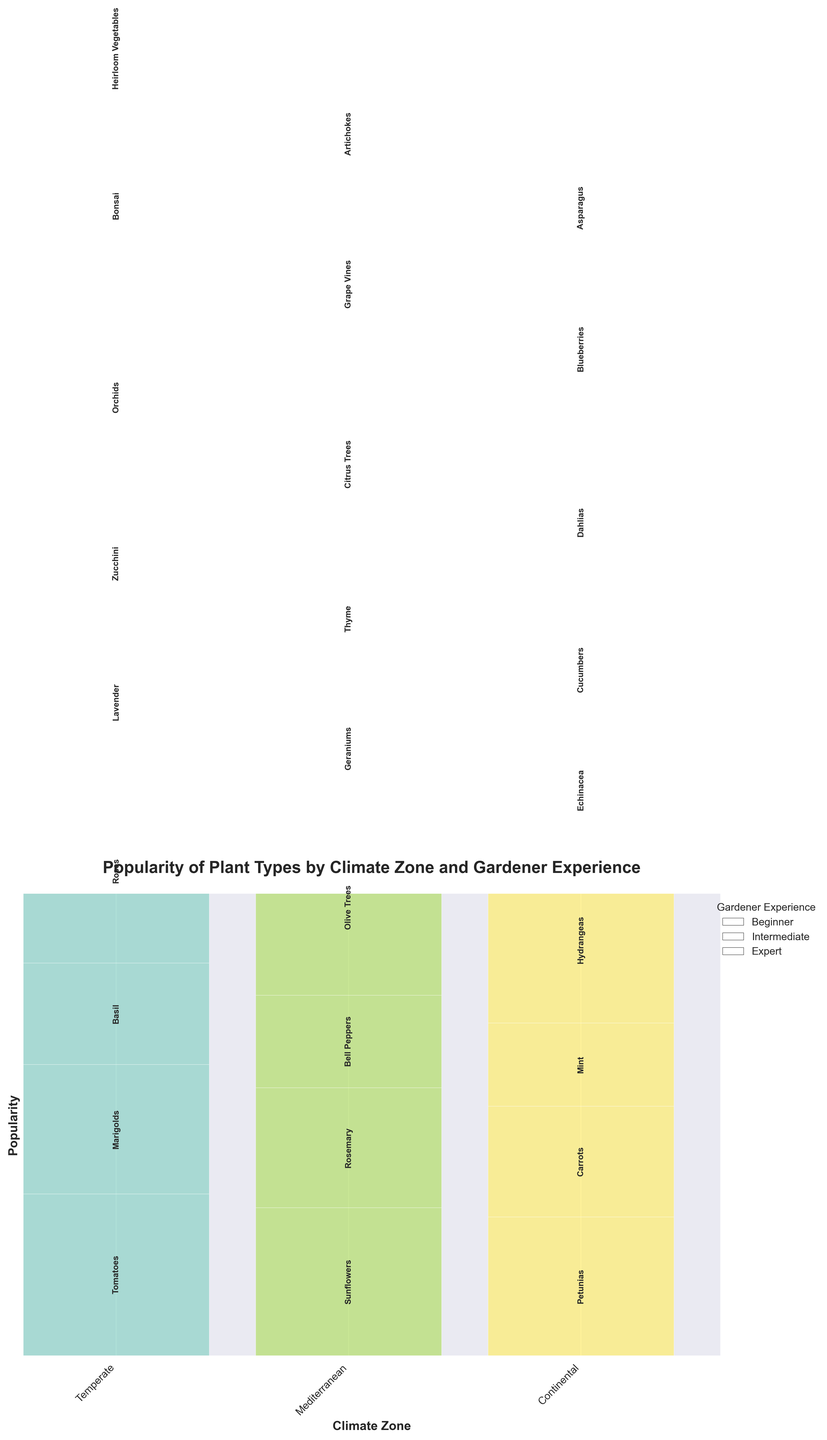What is the title of the plot? The title of the plot is placed at the top center and is written in bold font, making it easily identifiable.
Answer: Popularity of Plant Types by Climate Zone and Gardener Experience How many climate zones are represented in the plot? The x-axis labels represent different climate zones, shown as distinct categories.
Answer: 3 Which plant type is most popular among beginner gardeners in the Temperate zone? For Temperate beginners, visually identify the plant type with the tallest bar segment.
Answer: Tomatoes Among Mediterranean expert gardeners, are Citrus Trees or Grape Vines more popular? Compare the heights of the segments for Citrus Trees and Grape Vines under the Mediterranean expert category.
Answer: Citrus Trees What is the total popularity of plant types for Intermediate gardeners in the Continental climate? Sum the heights of all plant type segments within the Continental Intermediate gardener section.
Answer: 88 How does the popularity of Roses in the Temperate zone compare between beginner and intermediate gardeners? Compare the segment height for Roses in both beginner and intermediate gardener sections within the Temperate zone.
Answer: Higher for Intermediate Which climate zone and gardener experience combination shows the highest popularity for any plant type? Look for the tallest individual segment across all combinations of climate zones and experience levels.
Answer: Orchids in Temperate Expert What is the least popular plant type among beginner gardeners across all climate zones? Identify the shortest bar segment among all beginner gardener categories across all climate zones.
Answer: Mint How does the popularity of Zucchini for Intermediate gardeners compare between Temperate and Continental climate zones? Compare the segment heights for Zucchini within the Intermediate gardener section of both Temperate and Continental climate zones.
Answer: Higher in Temperate What plant types do expert gardeners favor most in the Mediterranean climate zone, and what is their combined popularity? Identify the plant types with highest segments and sum up their heights within the Mediterranean expert gardener section.
Answer: Citrus Trees and Grape Vines; 78 